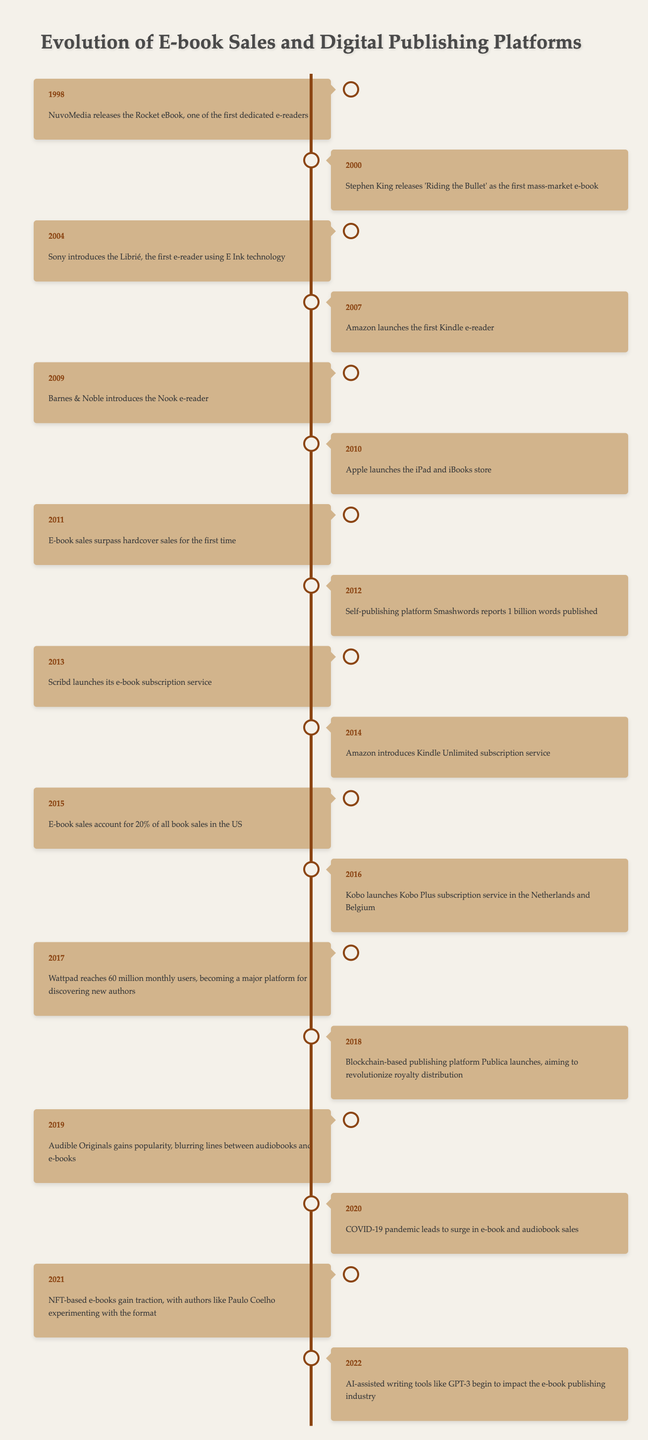What year did Stephen King release 'Riding the Bullet' as the first mass-market e-book? According to the timeline, the event states that Stephen King released 'Riding the Bullet' in the year 2000.
Answer: 2000 In what year did Amazon launch the first Kindle e-reader? The timeline indicates that Amazon launched the first Kindle e-reader in 2007.
Answer: 2007 How many years passed from the introduction of the Rocket eBook to when e-book sales surpassed hardcover sales? The Rocket eBook was released in 1998 and e-book sales surpassed hardcover sales in 2011. The difference in years is 2011 - 1998 = 13 years.
Answer: 13 years Did e-book sales account for 20% of all book sales in the US before 2015? The timeline shows that e-book sales accounted for 20% of all book sales in 2015. Therefore, prior to 2015, it was less than 20%.
Answer: No Which event marked the year when self-publishing platform Smashwords reported 1 billion words published? The event is noted in the timeline for the year 2012.
Answer: 2012 How many significant milestones in e-book sales and digital publishing occurred between 2000 and 2010? The timeline lists the following events in this range: 2000 - Stephen King releases 'Riding the Bullet'; 2004 - Sony introduces the Librié; 2007 - Amazon launches the Kindle; 2009 - Barnes & Noble introduces the Nook; 2010 - Apple launches the iPad and iBooks store. This sums up to 5 significant milestones.
Answer: 5 milestones What was a major event in the e-book industry that occurred in 2020? The timeline highlights that the COVID-19 pandemic led to a surge in e-book and audiobook sales in 2020 as a significant event.
Answer: Surge in sales due to COVID-19 Which event in 2018 aimed to revolutionize royalty distribution? The timeline specifies that in 2018, the blockchain-based publishing platform Publica launched, aiming to revolutionize royalty distribution.
Answer: Publica launches How many platforms or services were introduced between 2013 and 2021 according to the timeline? The timeline mentions Scribd's subscription service in 2013, Amazon's Kindle Unlimited service in 2014, Kobo's service in 2016, and the rise of NFT-based e-books in 2021. These four events indicate the introduction of 4 different platforms or services.
Answer: 4 platforms/services 